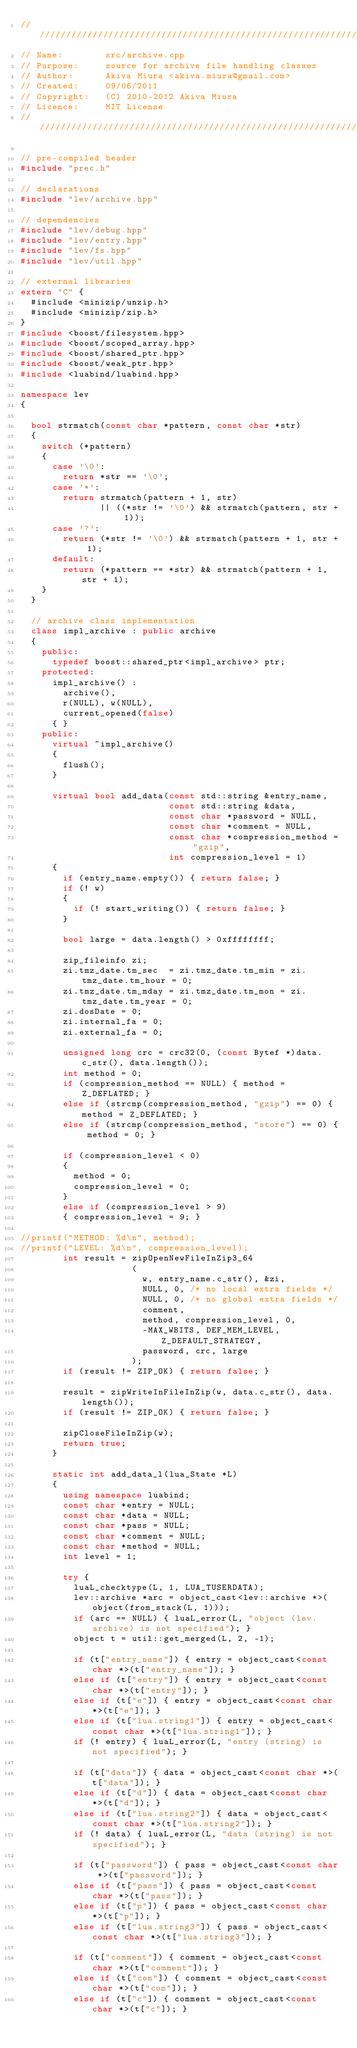<code> <loc_0><loc_0><loc_500><loc_500><_C++_>/////////////////////////////////////////////////////////////////////////////
// Name:        src/archive.cpp
// Purpose:     source for archive file handling classes
// Author:      Akiva Miura <akiva.miura@gmail.com>
// Created:     09/06/2011
// Copyright:   (C) 2010-2012 Akiva Miura
// Licence:     MIT License
/////////////////////////////////////////////////////////////////////////////

// pre-compiled header
#include "prec.h"

// declarations
#include "lev/archive.hpp"

// dependencies
#include "lev/debug.hpp"
#include "lev/entry.hpp"
#include "lev/fs.hpp"
#include "lev/util.hpp"

// external libraries
extern "C" {
  #include <minizip/unzip.h>
  #include <minizip/zip.h>
}
#include <boost/filesystem.hpp>
#include <boost/scoped_array.hpp>
#include <boost/shared_ptr.hpp>
#include <boost/weak_ptr.hpp>
#include <luabind/luabind.hpp>

namespace lev
{

  bool strmatch(const char *pattern, const char *str)
  {
    switch (*pattern)
    {
      case '\0':
        return *str == '\0';
      case '*':
        return strmatch(pattern + 1, str)
               || ((*str != '\0') && strmatch(pattern, str + 1));
      case '?':
        return (*str != '\0') && strmatch(pattern + 1, str + 1);
      default:
        return (*pattern == *str) && strmatch(pattern + 1, str + 1);
    }
  }

  // archive class implementation
  class impl_archive : public archive
  {
    public:
      typedef boost::shared_ptr<impl_archive> ptr;
    protected:
      impl_archive() :
        archive(),
        r(NULL), w(NULL),
        current_opened(false)
      { }
    public:
      virtual ~impl_archive()
      {
        flush();
      }

      virtual bool add_data(const std::string &entry_name,
                            const std::string &data,
                            const char *password = NULL,
                            const char *comment = NULL,
                            const char *compression_method = "gzip",
                            int compression_level = 1)
      {
        if (entry_name.empty()) { return false; }
        if (! w)
        {
          if (! start_writing()) { return false; }
        }

        bool large = data.length() > 0xffffffff;

        zip_fileinfo zi;
        zi.tmz_date.tm_sec  = zi.tmz_date.tm_min = zi.tmz_date.tm_hour = 0;
        zi.tmz_date.tm_mday = zi.tmz_date.tm_mon = zi.tmz_date.tm_year = 0;
        zi.dosDate = 0;
        zi.internal_fa = 0;
        zi.external_fa = 0;

        unsigned long crc = crc32(0, (const Bytef *)data.c_str(), data.length());
        int method = 0;
        if (compression_method == NULL) { method = Z_DEFLATED; }
        else if (strcmp(compression_method, "gzip") == 0) { method = Z_DEFLATED; }
        else if (strcmp(compression_method, "store") == 0) { method = 0; }

        if (compression_level < 0)
        {
          method = 0;
          compression_level = 0;
        }
        else if (compression_level > 9)
        { compression_level = 9; }

//printf("METHOD: %d\n", method);
//printf("LEVEL: %d\n", compression_level);
        int result = zipOpenNewFileInZip3_64
                     (
                       w, entry_name.c_str(), &zi,
                       NULL, 0, /* no local extra fields */
                       NULL, 0, /* no global extra fields */
                       comment,
                       method, compression_level, 0,
                       -MAX_WBITS, DEF_MEM_LEVEL, Z_DEFAULT_STRATEGY,
                       password, crc, large
                     );
        if (result != ZIP_OK) { return false; }

        result = zipWriteInFileInZip(w, data.c_str(), data.length());
        if (result != ZIP_OK) { return false; }

        zipCloseFileInZip(w);
        return true;
      }

      static int add_data_l(lua_State *L)
      {
        using namespace luabind;
        const char *entry = NULL;
        const char *data = NULL;
        const char *pass = NULL;
        const char *comment = NULL;
        const char *method = NULL;
        int level = 1;

        try {
          luaL_checktype(L, 1, LUA_TUSERDATA);
          lev::archive *arc = object_cast<lev::archive *>(object(from_stack(L, 1)));
          if (arc == NULL) { luaL_error(L, "object (lev.archive) is not specified"); }
          object t = util::get_merged(L, 2, -1);

          if (t["entry_name"]) { entry = object_cast<const char *>(t["entry_name"]); }
          else if (t["entry"]) { entry = object_cast<const char *>(t["entry"]); }
          else if (t["e"]) { entry = object_cast<const char *>(t["e"]); }
          else if (t["lua.string1"]) { entry = object_cast<const char *>(t["lua.string1"]); }
          if (! entry) { luaL_error(L, "entry (string) is not specified"); }

          if (t["data"]) { data = object_cast<const char *>(t["data"]); }
          else if (t["d"]) { data = object_cast<const char *>(t["d"]); }
          else if (t["lua.string2"]) { data = object_cast<const char *>(t["lua.string2"]); }
          if (! data) { luaL_error(L, "data (string) is not specified"); }

          if (t["password"]) { pass = object_cast<const char *>(t["password"]); }
          else if (t["pass"]) { pass = object_cast<const char *>(t["pass"]); }
          else if (t["p"]) { pass = object_cast<const char *>(t["p"]); }
          else if (t["lua.string3"]) { pass = object_cast<const char *>(t["lua.string3"]); }

          if (t["comment"]) { comment = object_cast<const char *>(t["comment"]); }
          else if (t["com"]) { comment = object_cast<const char *>(t["com"]); }
          else if (t["c"]) { comment = object_cast<const char *>(t["c"]); }</code> 